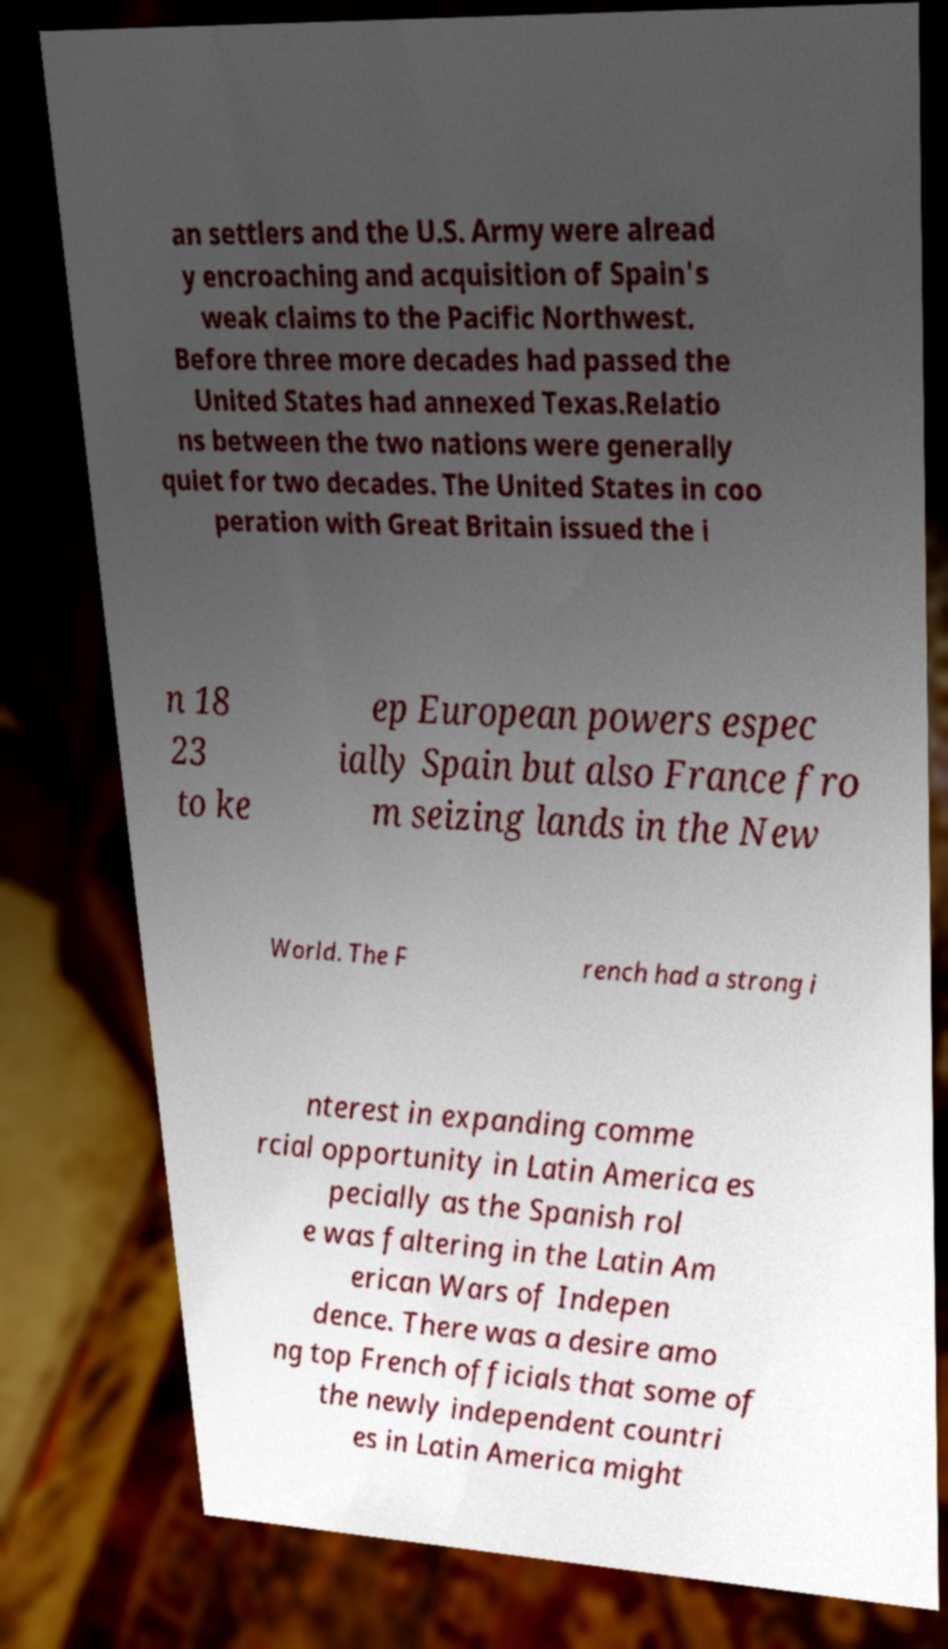There's text embedded in this image that I need extracted. Can you transcribe it verbatim? an settlers and the U.S. Army were alread y encroaching and acquisition of Spain's weak claims to the Pacific Northwest. Before three more decades had passed the United States had annexed Texas.Relatio ns between the two nations were generally quiet for two decades. The United States in coo peration with Great Britain issued the i n 18 23 to ke ep European powers espec ially Spain but also France fro m seizing lands in the New World. The F rench had a strong i nterest in expanding comme rcial opportunity in Latin America es pecially as the Spanish rol e was faltering in the Latin Am erican Wars of Indepen dence. There was a desire amo ng top French officials that some of the newly independent countri es in Latin America might 